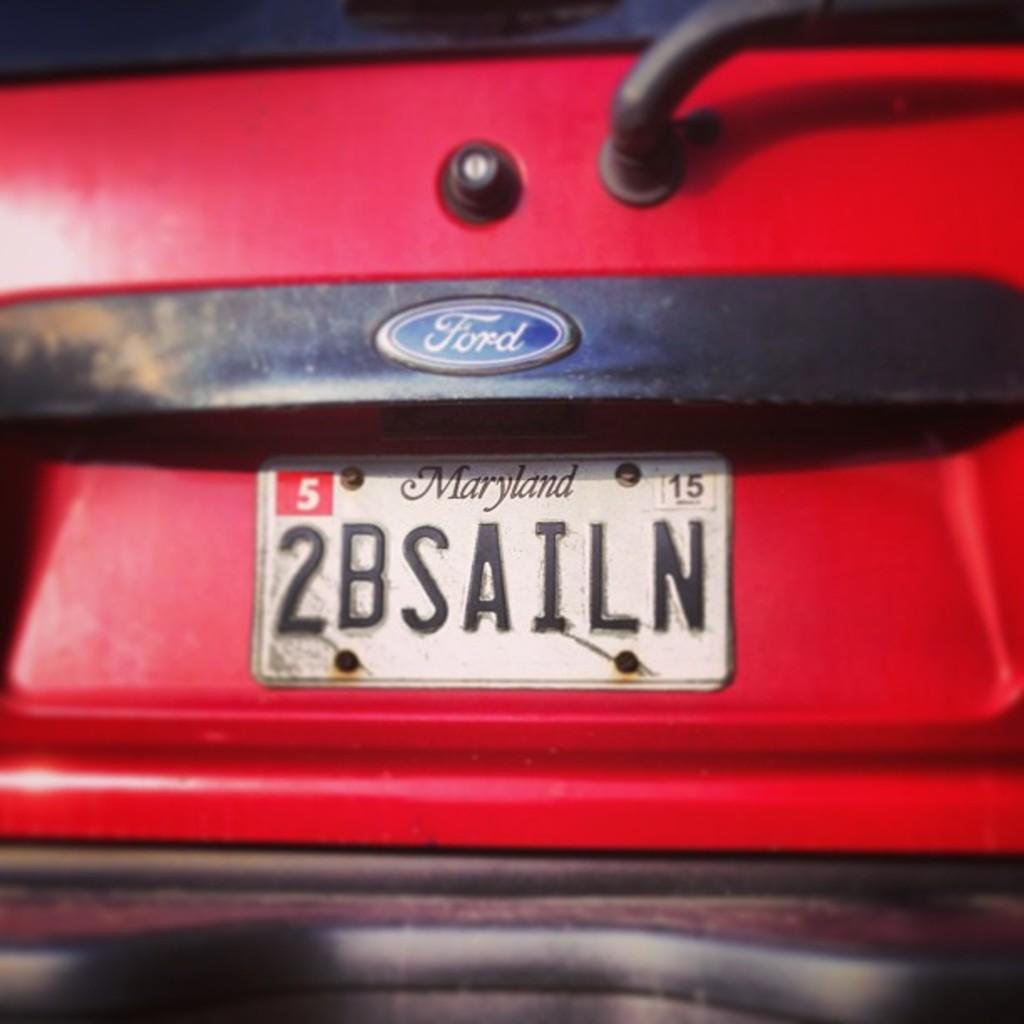What is the auto maker of this car?
Your response must be concise. Ford. 